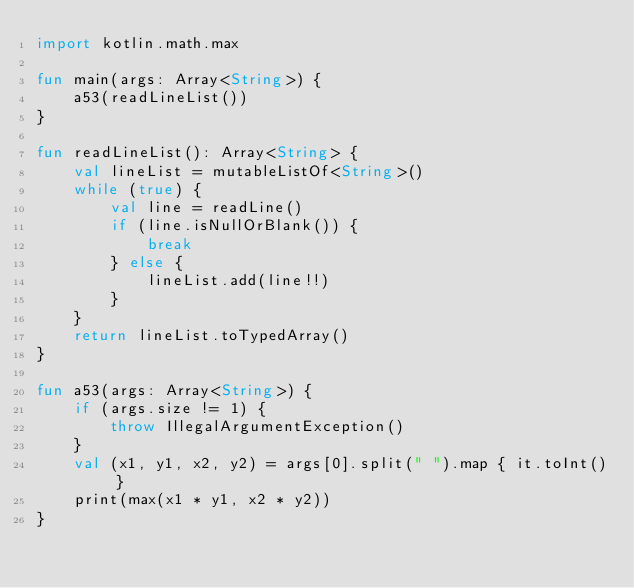<code> <loc_0><loc_0><loc_500><loc_500><_Kotlin_>import kotlin.math.max

fun main(args: Array<String>) {
    a53(readLineList())
}

fun readLineList(): Array<String> {
    val lineList = mutableListOf<String>()
    while (true) {
        val line = readLine()
        if (line.isNullOrBlank()) {
            break
        } else {
            lineList.add(line!!)
        }
    }
    return lineList.toTypedArray()
}

fun a53(args: Array<String>) {
    if (args.size != 1) {
        throw IllegalArgumentException()
    }
    val (x1, y1, x2, y2) = args[0].split(" ").map { it.toInt() }
    print(max(x1 * y1, x2 * y2))
}
</code> 